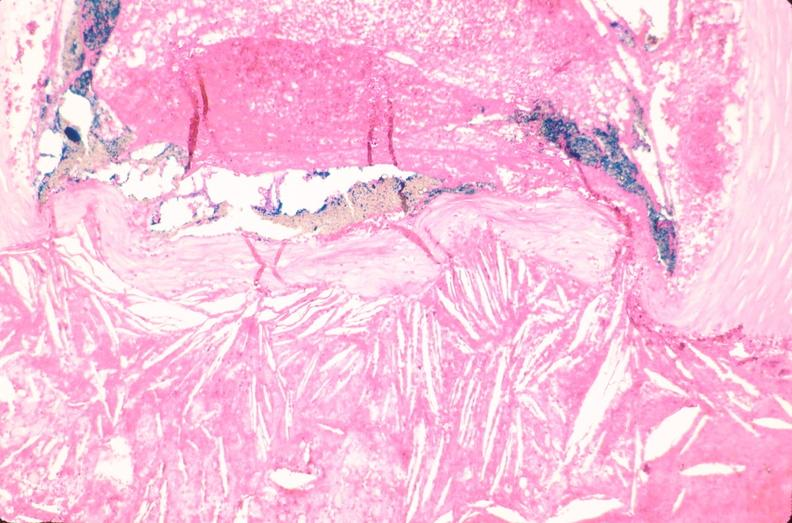what does this image show?
Answer the question using a single word or phrase. Coronary artery atherosclerosis 